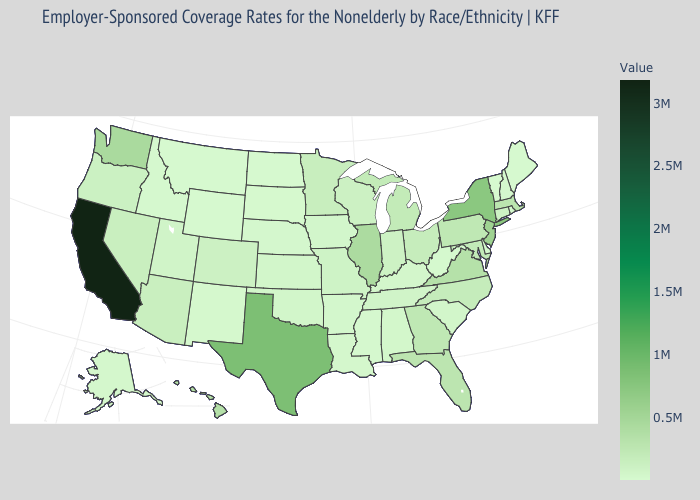Which states have the lowest value in the MidWest?
Give a very brief answer. North Dakota. Does Washington have a lower value than Texas?
Write a very short answer. Yes. Which states have the lowest value in the USA?
Answer briefly. Wyoming. Does Tennessee have a lower value than Texas?
Be succinct. Yes. 